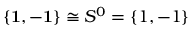Convert formula to latex. <formula><loc_0><loc_0><loc_500><loc_500>\{ { 1 } , - { 1 } \} \cong S ^ { 0 } = \{ 1 , - 1 \}</formula> 